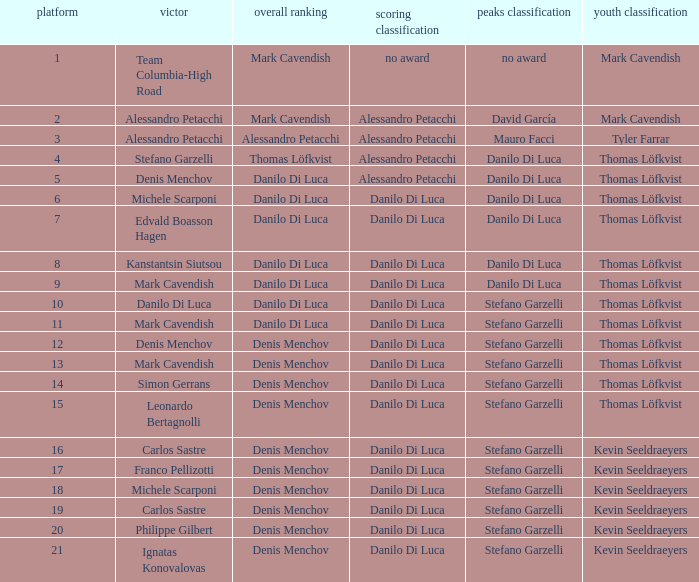If philippe gilbert wins, who clinches the points classification? Danilo Di Luca. 